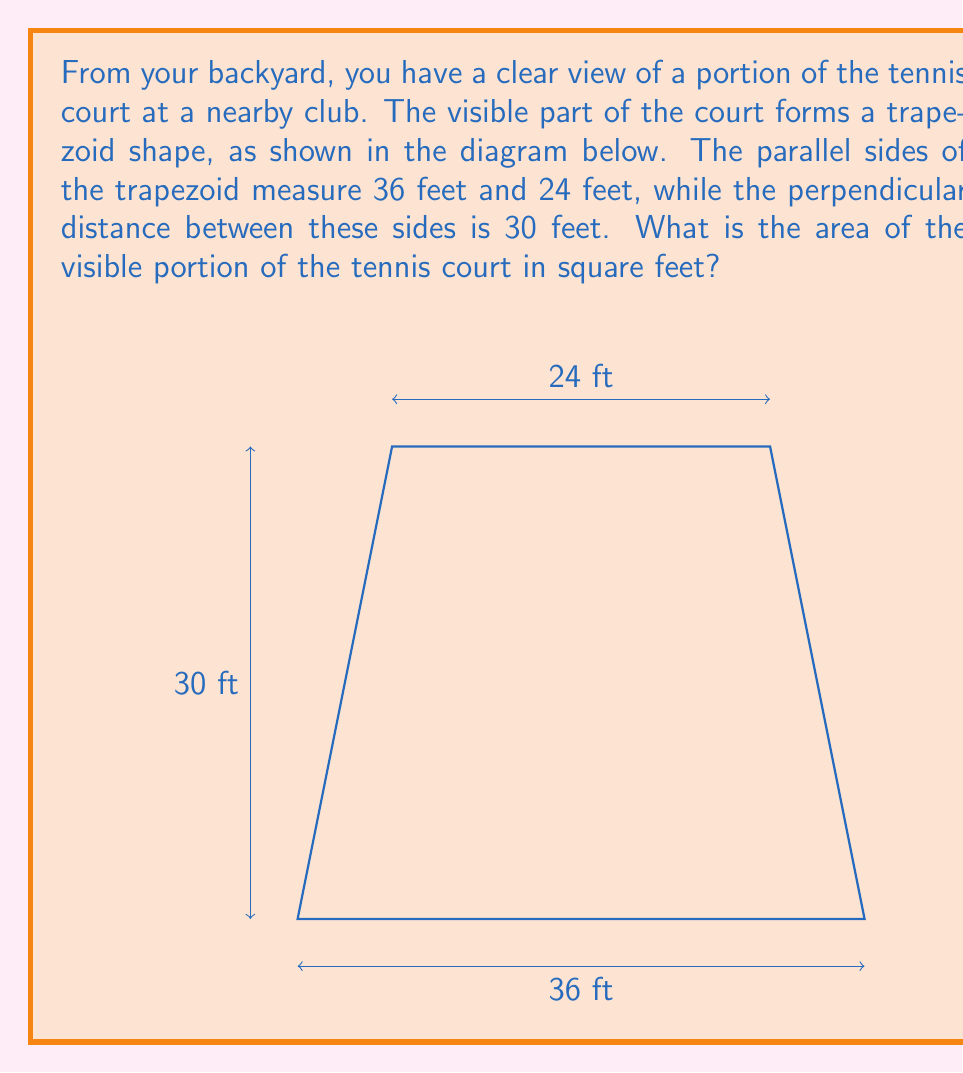Could you help me with this problem? Let's approach this step-by-step:

1) The shape we're dealing with is a trapezoid. The formula for the area of a trapezoid is:

   $$A = \frac{1}{2}(b_1 + b_2)h$$

   where $A$ is the area, $b_1$ and $b_2$ are the lengths of the parallel sides, and $h$ is the height (perpendicular distance between the parallel sides).

2) From the given information:
   $b_1 = 36$ feet (longer parallel side)
   $b_2 = 24$ feet (shorter parallel side)
   $h = 30$ feet (height)

3) Let's substitute these values into our formula:

   $$A = \frac{1}{2}(36 + 24) \times 30$$

4) First, add the parallel sides:
   
   $$A = \frac{1}{2}(60) \times 30$$

5) Multiply:
   
   $$A = 30 \times 30 = 900$$

Therefore, the area of the visible portion of the tennis court is 900 square feet.
Answer: 900 sq ft 